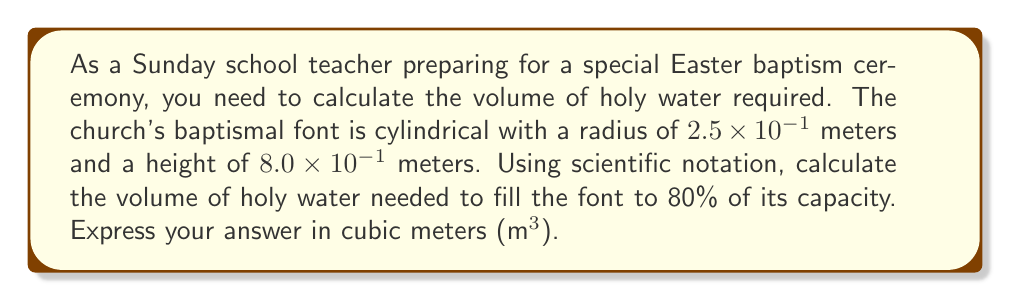Give your solution to this math problem. To solve this problem, let's follow these steps:

1) First, recall the formula for the volume of a cylinder:
   $$V = \pi r^2 h$$
   where $r$ is the radius and $h$ is the height.

2) We're given:
   $r = 2.5 \times 10^{-1}$ m
   $h = 8.0 \times 10^{-1}$ m

3) Let's substitute these into our formula:
   $$V = \pi (2.5 \times 10^{-1})^2 (8.0 \times 10^{-1})$$

4) Simplify the exponents:
   $$V = \pi (6.25 \times 10^{-2}) (8.0 \times 10^{-1})$$

5) Multiply the numbers:
   $$V = \pi (5.0 \times 10^{-2})$$

6) Multiply by $\pi$:
   $$V \approx 1.57 \times 10^{-1}$$ m³

7) However, we only need to fill the font to 80% of its capacity. So we multiply by 0.8:
   $$V_{80\%} = (1.57 \times 10^{-1})(0.8) = 1.256 \times 10^{-1}$$ m³

8) Rounding to 3 significant figures:
   $$V_{80\%} \approx 1.26 \times 10^{-1}$$ m³
Answer: $1.26 \times 10^{-1}$ m³ 